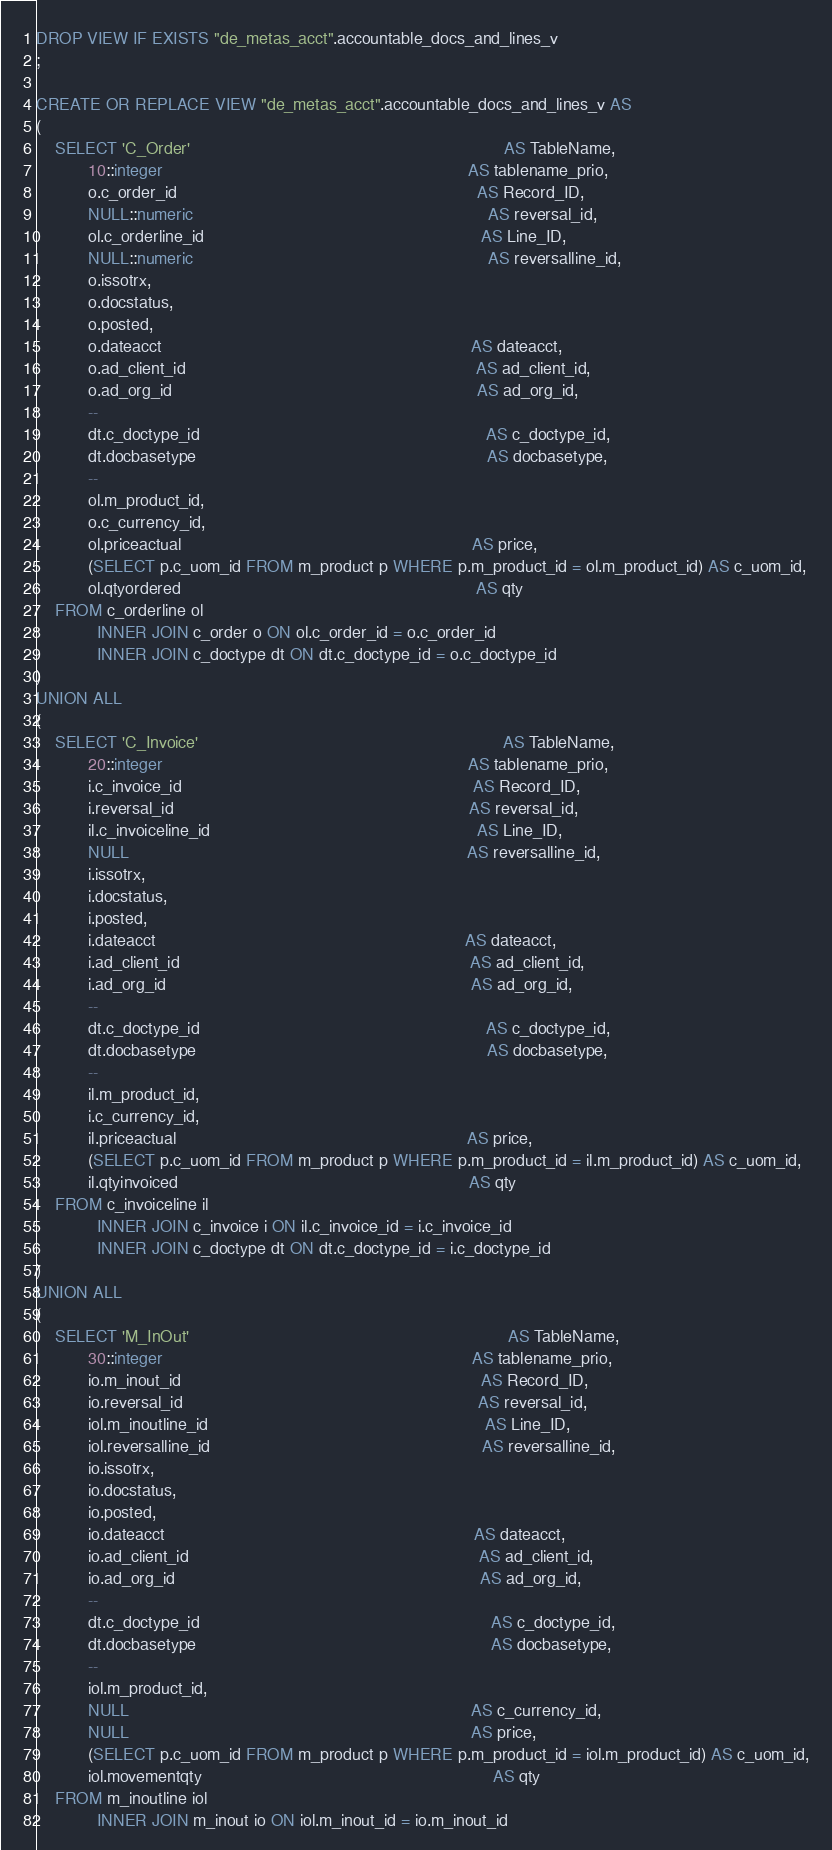<code> <loc_0><loc_0><loc_500><loc_500><_SQL_>DROP VIEW IF EXISTS "de_metas_acct".accountable_docs_and_lines_v
;

CREATE OR REPLACE VIEW "de_metas_acct".accountable_docs_and_lines_v AS
(
    SELECT 'C_Order'                                                                   AS TableName,
           10::integer                                                                 AS tablename_prio,
           o.c_order_id                                                                AS Record_ID,
           NULL::numeric                                                               AS reversal_id,
           ol.c_orderline_id                                                           AS Line_ID,
           NULL::numeric                                                               AS reversalline_id,
           o.issotrx,
           o.docstatus,
           o.posted,
           o.dateacct                                                                  AS dateacct,
           o.ad_client_id                                                              AS ad_client_id,
           o.ad_org_id                                                                 AS ad_org_id,
           --
           dt.c_doctype_id                                                             AS c_doctype_id,
           dt.docbasetype                                                              AS docbasetype,
           --
           ol.m_product_id,
           o.c_currency_id,
           ol.priceactual                                                              AS price,
           (SELECT p.c_uom_id FROM m_product p WHERE p.m_product_id = ol.m_product_id) AS c_uom_id,
           ol.qtyordered                                                               AS qty
    FROM c_orderline ol
             INNER JOIN c_order o ON ol.c_order_id = o.c_order_id
             INNER JOIN c_doctype dt ON dt.c_doctype_id = o.c_doctype_id
)
UNION ALL
(
    SELECT 'C_Invoice'                                                                 AS TableName,
           20::integer                                                                 AS tablename_prio,
           i.c_invoice_id                                                              AS Record_ID,
           i.reversal_id                                                               AS reversal_id,
           il.c_invoiceline_id                                                         AS Line_ID,
           NULL                                                                        AS reversalline_id,
           i.issotrx,
           i.docstatus,
           i.posted,
           i.dateacct                                                                  AS dateacct,
           i.ad_client_id                                                              AS ad_client_id,
           i.ad_org_id                                                                 AS ad_org_id,
           --
           dt.c_doctype_id                                                             AS c_doctype_id,
           dt.docbasetype                                                              AS docbasetype,
           --
           il.m_product_id,
           i.c_currency_id,
           il.priceactual                                                              AS price,
           (SELECT p.c_uom_id FROM m_product p WHERE p.m_product_id = il.m_product_id) AS c_uom_id,
           il.qtyinvoiced                                                              AS qty
    FROM c_invoiceline il
             INNER JOIN c_invoice i ON il.c_invoice_id = i.c_invoice_id
             INNER JOIN c_doctype dt ON dt.c_doctype_id = i.c_doctype_id
)
UNION ALL
(
    SELECT 'M_InOut'                                                                    AS TableName,
           30::integer                                                                  AS tablename_prio,
           io.m_inout_id                                                                AS Record_ID,
           io.reversal_id                                                               AS reversal_id,
           iol.m_inoutline_id                                                           AS Line_ID,
           iol.reversalline_id                                                          AS reversalline_id,
           io.issotrx,
           io.docstatus,
           io.posted,
           io.dateacct                                                                  AS dateacct,
           io.ad_client_id                                                              AS ad_client_id,
           io.ad_org_id                                                                 AS ad_org_id,
           --
           dt.c_doctype_id                                                              AS c_doctype_id,
           dt.docbasetype                                                               AS docbasetype,
           --
           iol.m_product_id,
           NULL                                                                         AS c_currency_id,
           NULL                                                                         AS price,
           (SELECT p.c_uom_id FROM m_product p WHERE p.m_product_id = iol.m_product_id) AS c_uom_id,
           iol.movementqty                                                              AS qty
    FROM m_inoutline iol
             INNER JOIN m_inout io ON iol.m_inout_id = io.m_inout_id</code> 